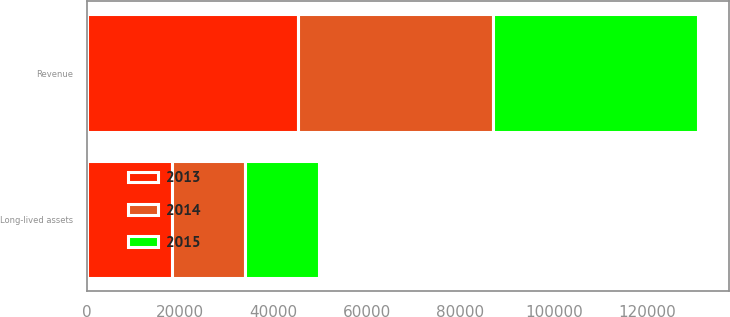Convert chart to OTSL. <chart><loc_0><loc_0><loc_500><loc_500><stacked_bar_chart><ecel><fcel>Revenue<fcel>Long-lived assets<nl><fcel>2013<fcel>45309<fcel>18196<nl><fcel>2015<fcel>43840<fcel>15902<nl><fcel>2014<fcel>41772<fcel>15651<nl></chart> 